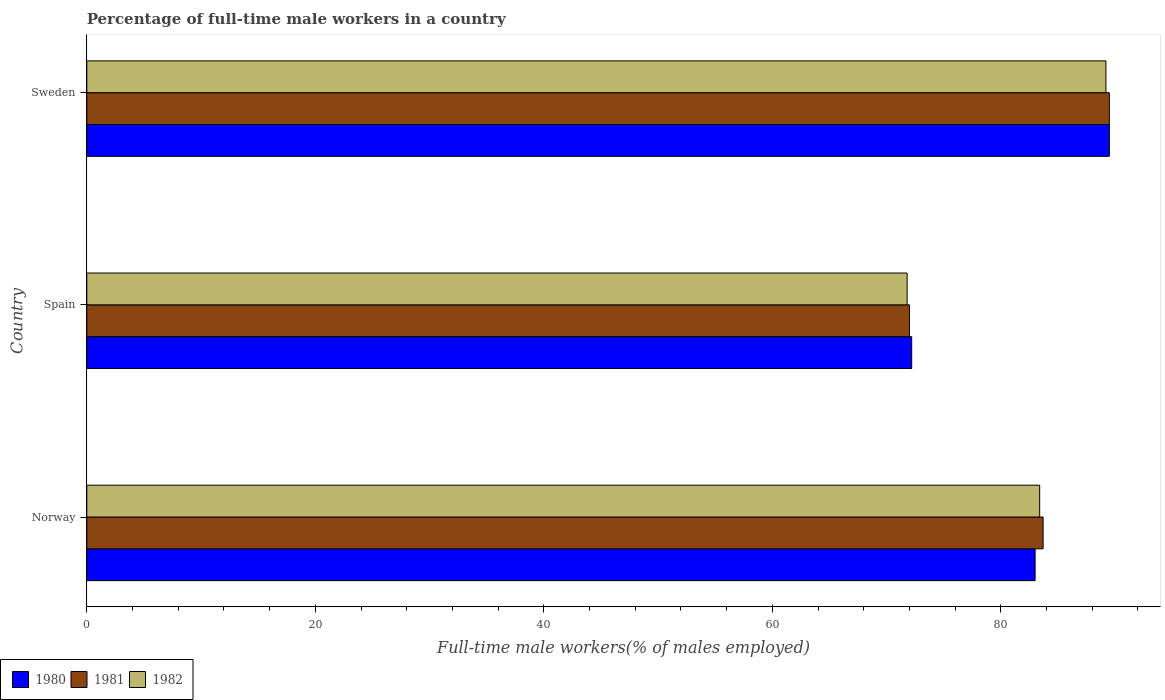How many groups of bars are there?
Provide a short and direct response. 3. Are the number of bars on each tick of the Y-axis equal?
Give a very brief answer. Yes. How many bars are there on the 2nd tick from the bottom?
Give a very brief answer. 3. In how many cases, is the number of bars for a given country not equal to the number of legend labels?
Ensure brevity in your answer.  0. What is the percentage of full-time male workers in 1982 in Spain?
Offer a terse response. 71.8. Across all countries, what is the maximum percentage of full-time male workers in 1982?
Give a very brief answer. 89.2. Across all countries, what is the minimum percentage of full-time male workers in 1982?
Ensure brevity in your answer.  71.8. In which country was the percentage of full-time male workers in 1981 maximum?
Your answer should be very brief. Sweden. What is the total percentage of full-time male workers in 1982 in the graph?
Provide a succinct answer. 244.4. What is the difference between the percentage of full-time male workers in 1981 in Norway and that in Sweden?
Provide a succinct answer. -5.8. What is the difference between the percentage of full-time male workers in 1980 in Spain and the percentage of full-time male workers in 1981 in Sweden?
Your answer should be very brief. -17.3. What is the average percentage of full-time male workers in 1980 per country?
Make the answer very short. 81.57. What is the difference between the percentage of full-time male workers in 1980 and percentage of full-time male workers in 1981 in Spain?
Offer a terse response. 0.2. What is the ratio of the percentage of full-time male workers in 1980 in Spain to that in Sweden?
Provide a short and direct response. 0.81. Is the percentage of full-time male workers in 1980 in Norway less than that in Spain?
Ensure brevity in your answer.  No. What is the difference between the highest and the second highest percentage of full-time male workers in 1982?
Your answer should be compact. 5.8. What is the difference between the highest and the lowest percentage of full-time male workers in 1982?
Ensure brevity in your answer.  17.4. What does the 2nd bar from the top in Norway represents?
Offer a terse response. 1981. Are all the bars in the graph horizontal?
Ensure brevity in your answer.  Yes. How many countries are there in the graph?
Provide a short and direct response. 3. What is the difference between two consecutive major ticks on the X-axis?
Keep it short and to the point. 20. What is the title of the graph?
Provide a short and direct response. Percentage of full-time male workers in a country. What is the label or title of the X-axis?
Give a very brief answer. Full-time male workers(% of males employed). What is the Full-time male workers(% of males employed) in 1981 in Norway?
Your answer should be compact. 83.7. What is the Full-time male workers(% of males employed) of 1982 in Norway?
Keep it short and to the point. 83.4. What is the Full-time male workers(% of males employed) in 1980 in Spain?
Provide a succinct answer. 72.2. What is the Full-time male workers(% of males employed) in 1982 in Spain?
Give a very brief answer. 71.8. What is the Full-time male workers(% of males employed) in 1980 in Sweden?
Provide a short and direct response. 89.5. What is the Full-time male workers(% of males employed) of 1981 in Sweden?
Offer a very short reply. 89.5. What is the Full-time male workers(% of males employed) in 1982 in Sweden?
Offer a terse response. 89.2. Across all countries, what is the maximum Full-time male workers(% of males employed) of 1980?
Your response must be concise. 89.5. Across all countries, what is the maximum Full-time male workers(% of males employed) in 1981?
Keep it short and to the point. 89.5. Across all countries, what is the maximum Full-time male workers(% of males employed) in 1982?
Make the answer very short. 89.2. Across all countries, what is the minimum Full-time male workers(% of males employed) of 1980?
Offer a terse response. 72.2. Across all countries, what is the minimum Full-time male workers(% of males employed) in 1982?
Offer a very short reply. 71.8. What is the total Full-time male workers(% of males employed) of 1980 in the graph?
Offer a very short reply. 244.7. What is the total Full-time male workers(% of males employed) in 1981 in the graph?
Make the answer very short. 245.2. What is the total Full-time male workers(% of males employed) of 1982 in the graph?
Offer a very short reply. 244.4. What is the difference between the Full-time male workers(% of males employed) of 1981 in Norway and that in Spain?
Make the answer very short. 11.7. What is the difference between the Full-time male workers(% of males employed) in 1980 in Norway and that in Sweden?
Offer a terse response. -6.5. What is the difference between the Full-time male workers(% of males employed) of 1981 in Norway and that in Sweden?
Ensure brevity in your answer.  -5.8. What is the difference between the Full-time male workers(% of males employed) in 1980 in Spain and that in Sweden?
Provide a short and direct response. -17.3. What is the difference between the Full-time male workers(% of males employed) of 1981 in Spain and that in Sweden?
Your response must be concise. -17.5. What is the difference between the Full-time male workers(% of males employed) of 1982 in Spain and that in Sweden?
Make the answer very short. -17.4. What is the difference between the Full-time male workers(% of males employed) in 1980 in Norway and the Full-time male workers(% of males employed) in 1981 in Spain?
Your answer should be compact. 11. What is the difference between the Full-time male workers(% of males employed) in 1980 in Norway and the Full-time male workers(% of males employed) in 1982 in Spain?
Your answer should be very brief. 11.2. What is the difference between the Full-time male workers(% of males employed) of 1981 in Norway and the Full-time male workers(% of males employed) of 1982 in Spain?
Your answer should be compact. 11.9. What is the difference between the Full-time male workers(% of males employed) of 1980 in Norway and the Full-time male workers(% of males employed) of 1982 in Sweden?
Make the answer very short. -6.2. What is the difference between the Full-time male workers(% of males employed) of 1980 in Spain and the Full-time male workers(% of males employed) of 1981 in Sweden?
Make the answer very short. -17.3. What is the difference between the Full-time male workers(% of males employed) of 1981 in Spain and the Full-time male workers(% of males employed) of 1982 in Sweden?
Your answer should be very brief. -17.2. What is the average Full-time male workers(% of males employed) in 1980 per country?
Ensure brevity in your answer.  81.57. What is the average Full-time male workers(% of males employed) of 1981 per country?
Offer a terse response. 81.73. What is the average Full-time male workers(% of males employed) in 1982 per country?
Keep it short and to the point. 81.47. What is the difference between the Full-time male workers(% of males employed) of 1980 and Full-time male workers(% of males employed) of 1981 in Norway?
Make the answer very short. -0.7. What is the difference between the Full-time male workers(% of males employed) of 1980 and Full-time male workers(% of males employed) of 1982 in Norway?
Offer a terse response. -0.4. What is the difference between the Full-time male workers(% of males employed) of 1980 and Full-time male workers(% of males employed) of 1982 in Spain?
Keep it short and to the point. 0.4. What is the difference between the Full-time male workers(% of males employed) in 1981 and Full-time male workers(% of males employed) in 1982 in Spain?
Your answer should be compact. 0.2. What is the difference between the Full-time male workers(% of males employed) in 1980 and Full-time male workers(% of males employed) in 1981 in Sweden?
Your answer should be very brief. 0. What is the difference between the Full-time male workers(% of males employed) in 1980 and Full-time male workers(% of males employed) in 1982 in Sweden?
Give a very brief answer. 0.3. What is the difference between the Full-time male workers(% of males employed) of 1981 and Full-time male workers(% of males employed) of 1982 in Sweden?
Ensure brevity in your answer.  0.3. What is the ratio of the Full-time male workers(% of males employed) of 1980 in Norway to that in Spain?
Give a very brief answer. 1.15. What is the ratio of the Full-time male workers(% of males employed) in 1981 in Norway to that in Spain?
Provide a short and direct response. 1.16. What is the ratio of the Full-time male workers(% of males employed) of 1982 in Norway to that in Spain?
Keep it short and to the point. 1.16. What is the ratio of the Full-time male workers(% of males employed) of 1980 in Norway to that in Sweden?
Give a very brief answer. 0.93. What is the ratio of the Full-time male workers(% of males employed) of 1981 in Norway to that in Sweden?
Provide a succinct answer. 0.94. What is the ratio of the Full-time male workers(% of males employed) in 1982 in Norway to that in Sweden?
Your answer should be compact. 0.94. What is the ratio of the Full-time male workers(% of males employed) in 1980 in Spain to that in Sweden?
Provide a short and direct response. 0.81. What is the ratio of the Full-time male workers(% of males employed) of 1981 in Spain to that in Sweden?
Keep it short and to the point. 0.8. What is the ratio of the Full-time male workers(% of males employed) in 1982 in Spain to that in Sweden?
Give a very brief answer. 0.8. What is the difference between the highest and the second highest Full-time male workers(% of males employed) of 1982?
Your answer should be very brief. 5.8. What is the difference between the highest and the lowest Full-time male workers(% of males employed) of 1981?
Your response must be concise. 17.5. What is the difference between the highest and the lowest Full-time male workers(% of males employed) in 1982?
Offer a terse response. 17.4. 